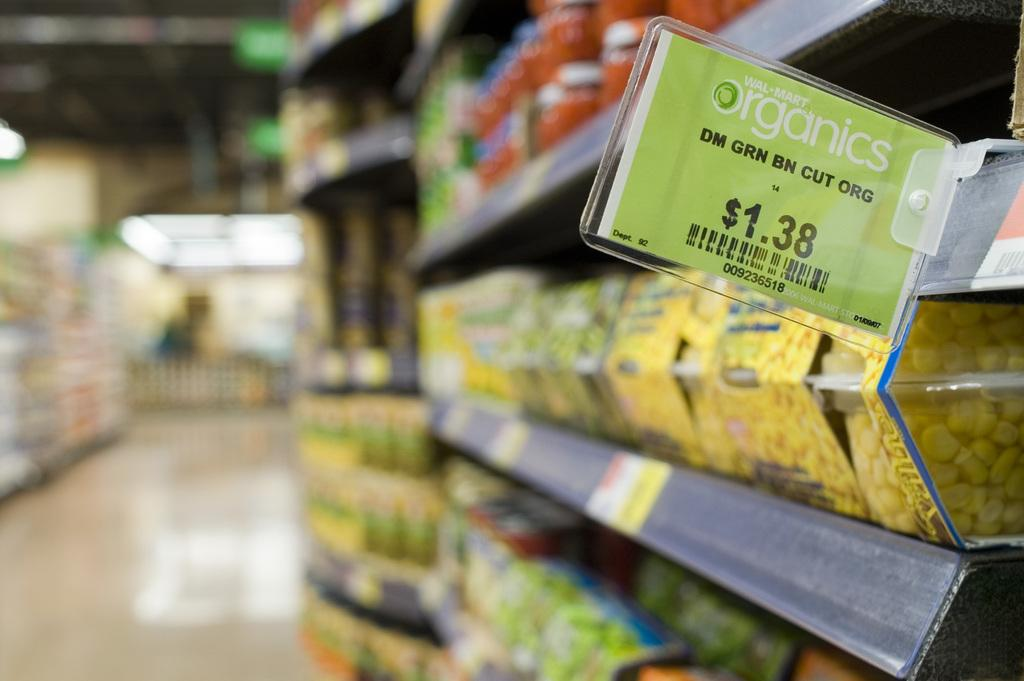Provide a one-sentence caption for the provided image. A sign in a market shows that organic cut green beans sell for $1.38. 